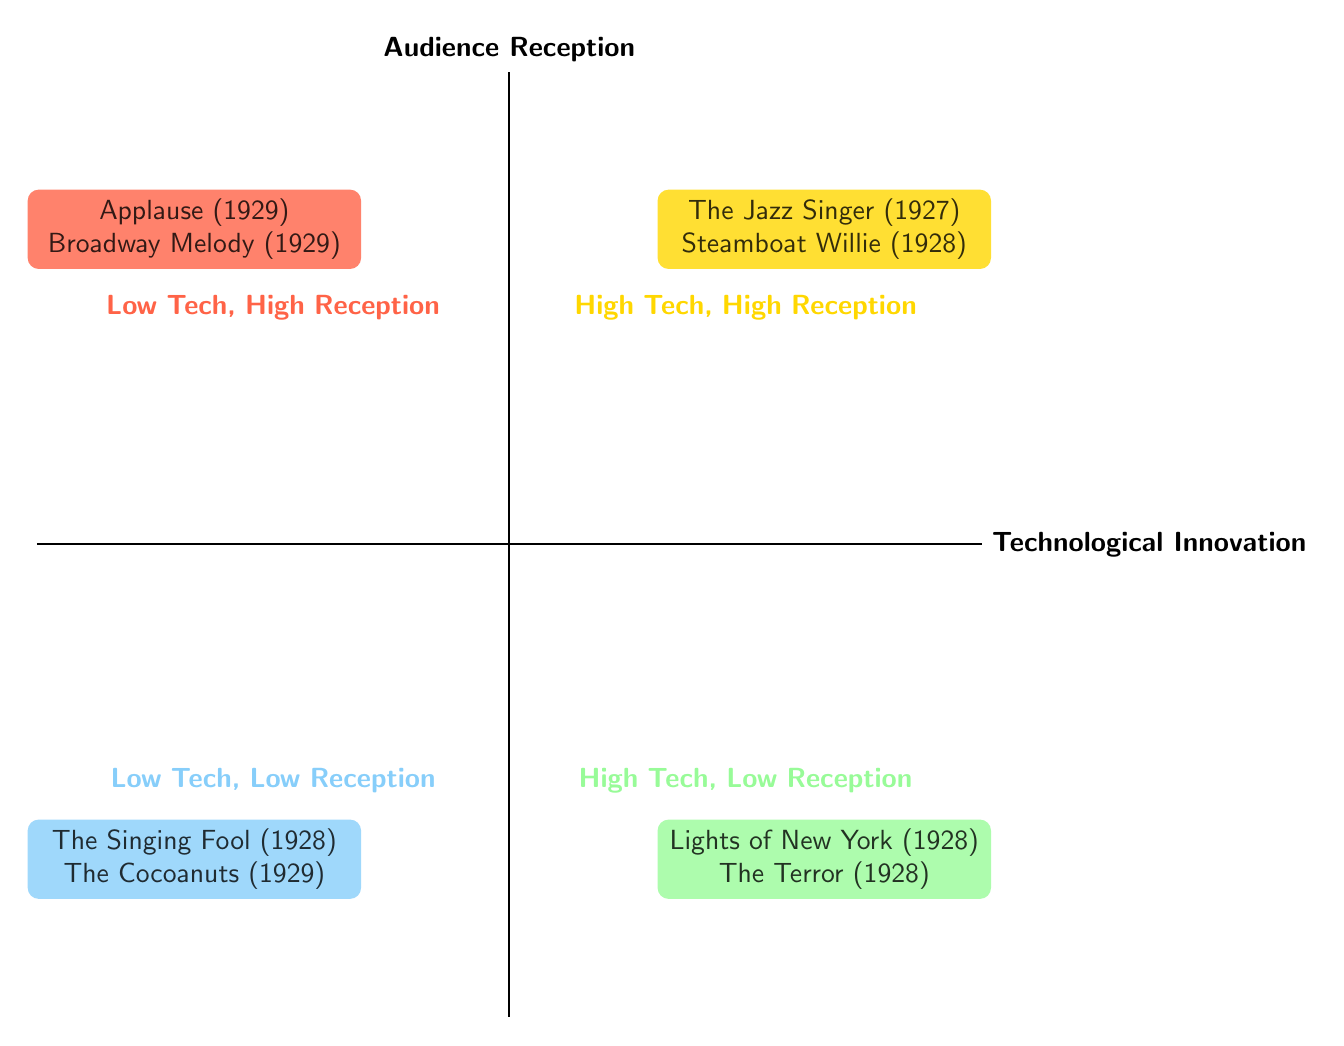What films are listed in the High Technological Innovation, High Audience Reception quadrant? This quadrant contains entries that have both high technological innovation and high audience reception, specifically The Jazz Singer and Steamboat Willie.
Answer: The Jazz Singer, Steamboat Willie How many films are displayed in the Low Technological Innovation, Low Audience Reception quadrant? This quadrant shows the films that ranked low in both technology and audience reception, which contain two films: The Singing Fool and The Cocoanuts.
Answer: 2 Which film is the first all-talking feature film? This aspect is associated with the High Technological Innovation, Low Audience Reception quadrant where Lights of New York is mentioned as the first all-talking feature film.
Answer: Lights of New York Are there any films that received high audience reception but had low technological innovation? This asks if any films were categorized as having low technological innovation yet received a high audience reception, revealing two films: Applause and Broadway Melody in that quadrant.
Answer: Yes What is the relationship between Lights of New York and audience reception? Lights of New York is positioned in the High Technological Innovation, Low Audience Reception quadrant, indicating it had significant technological achievements but suffered from poor audience reception.
Answer: Poor reception Which film won the Best Picture Academy Award? An inquiry about identifying a film that achieved the highest honor among audience reception and technological innovation, locating Broadway Melody in the Low Technological Innovation, High Audience Reception quadrant as the Academy Award winner.
Answer: Broadway Melody 